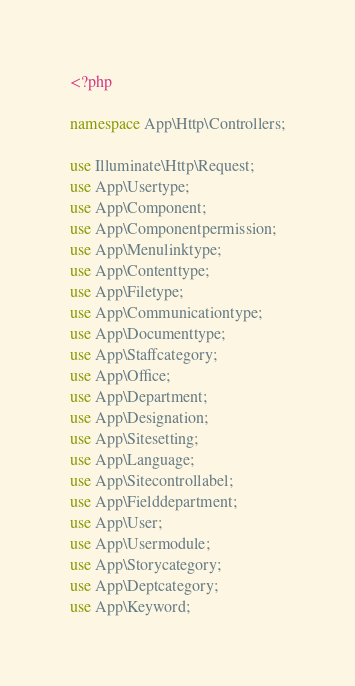<code> <loc_0><loc_0><loc_500><loc_500><_PHP_><?php

namespace App\Http\Controllers;

use Illuminate\Http\Request;
use App\Usertype;
use App\Component;
use App\Componentpermission;
use App\Menulinktype;
use App\Contenttype;
use App\Filetype;
use App\Communicationtype;
use App\Documenttype;
use App\Staffcategory;
use App\Office;
use App\Department;
use App\Designation;
use App\Sitesetting;
use App\Language;
use App\Sitecontrollabel;
use App\Fielddepartment;
use App\User;
use App\Usermodule;
use App\Storycategory;
use App\Deptcategory;
use App\Keyword;</code> 